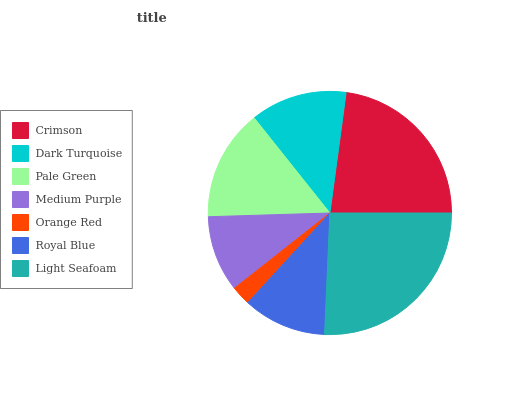Is Orange Red the minimum?
Answer yes or no. Yes. Is Light Seafoam the maximum?
Answer yes or no. Yes. Is Dark Turquoise the minimum?
Answer yes or no. No. Is Dark Turquoise the maximum?
Answer yes or no. No. Is Crimson greater than Dark Turquoise?
Answer yes or no. Yes. Is Dark Turquoise less than Crimson?
Answer yes or no. Yes. Is Dark Turquoise greater than Crimson?
Answer yes or no. No. Is Crimson less than Dark Turquoise?
Answer yes or no. No. Is Dark Turquoise the high median?
Answer yes or no. Yes. Is Dark Turquoise the low median?
Answer yes or no. Yes. Is Pale Green the high median?
Answer yes or no. No. Is Pale Green the low median?
Answer yes or no. No. 